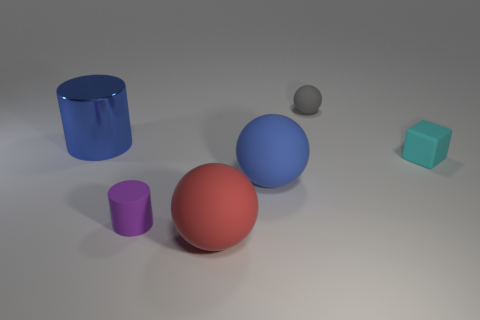Add 1 blue rubber things. How many objects exist? 7 Subtract all cubes. How many objects are left? 5 Add 2 purple rubber things. How many purple rubber things exist? 3 Subtract 0 red cylinders. How many objects are left? 6 Subtract all matte things. Subtract all tiny cyan matte things. How many objects are left? 0 Add 4 small purple matte things. How many small purple matte things are left? 5 